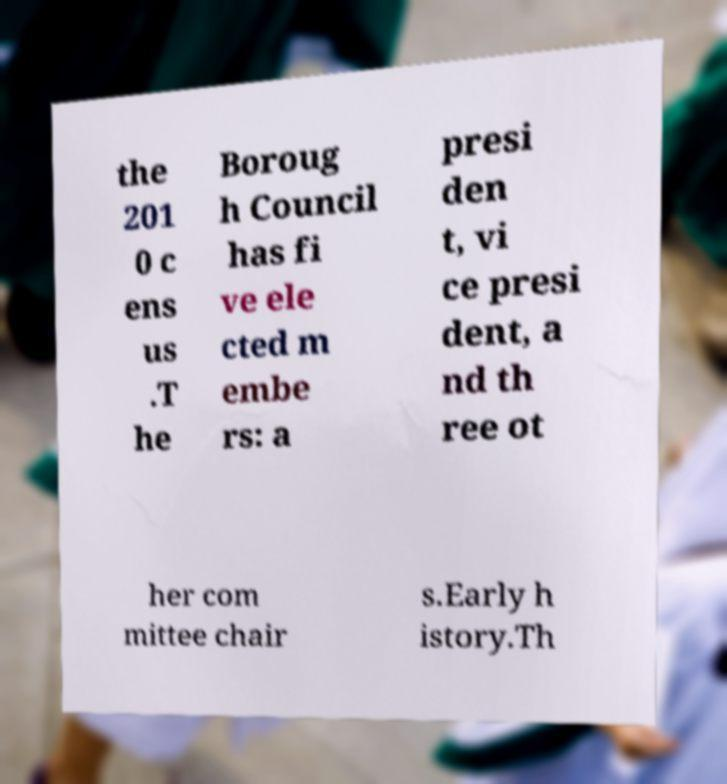I need the written content from this picture converted into text. Can you do that? the 201 0 c ens us .T he Boroug h Council has fi ve ele cted m embe rs: a presi den t, vi ce presi dent, a nd th ree ot her com mittee chair s.Early h istory.Th 